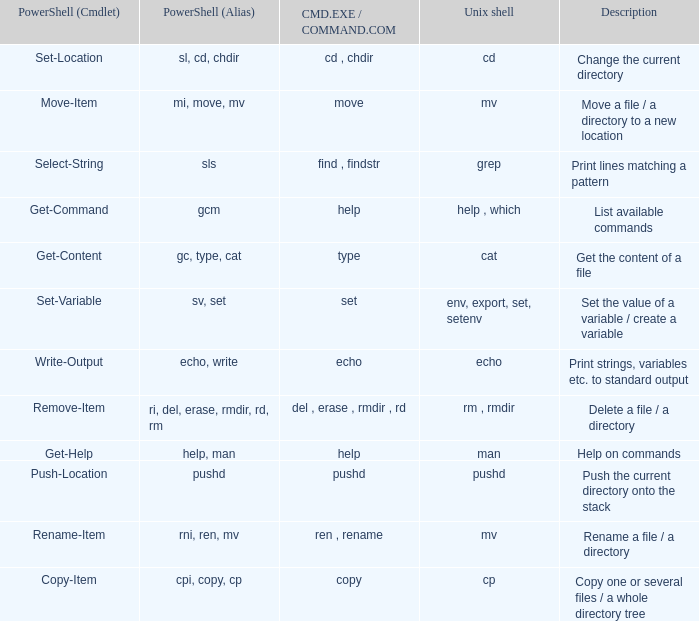How many values of powershell (cmdlet) are valid when unix shell is env, export, set, setenv? 1.0. 